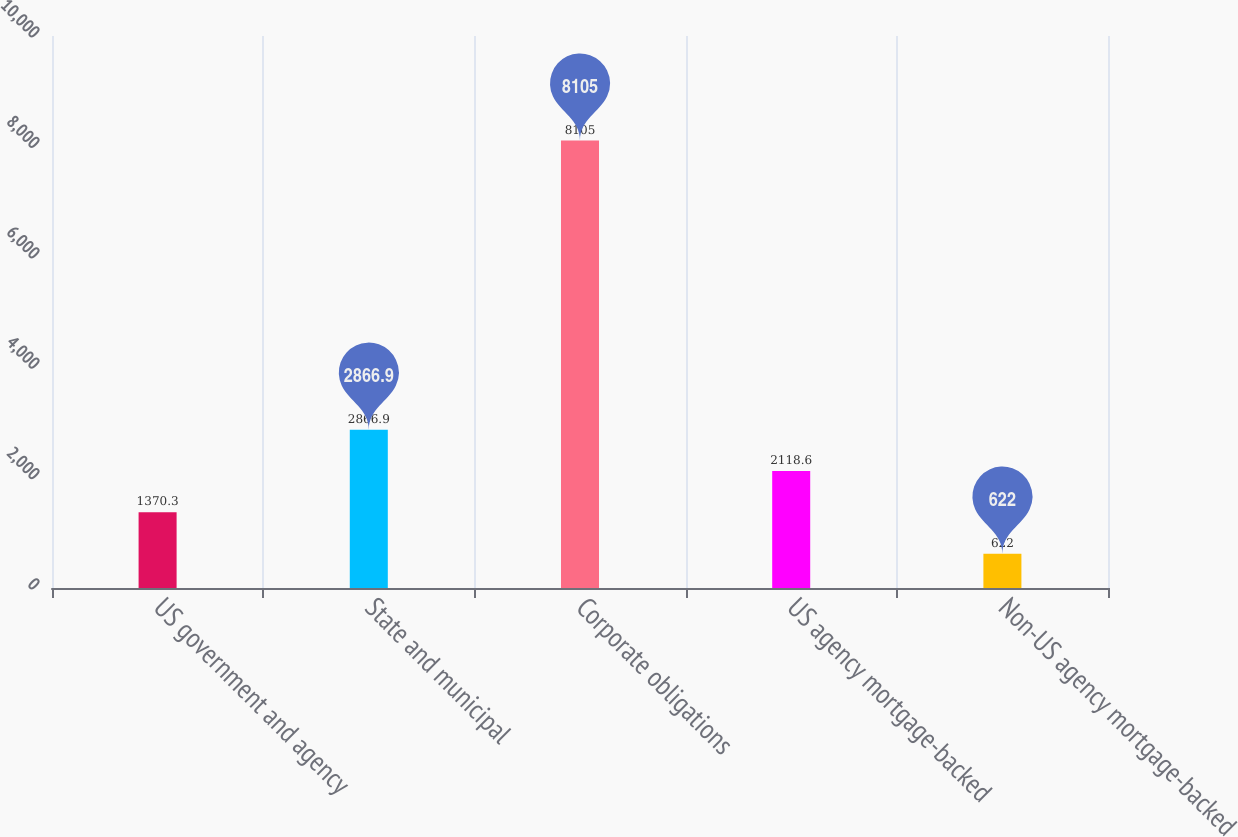Convert chart to OTSL. <chart><loc_0><loc_0><loc_500><loc_500><bar_chart><fcel>US government and agency<fcel>State and municipal<fcel>Corporate obligations<fcel>US agency mortgage-backed<fcel>Non-US agency mortgage-backed<nl><fcel>1370.3<fcel>2866.9<fcel>8105<fcel>2118.6<fcel>622<nl></chart> 